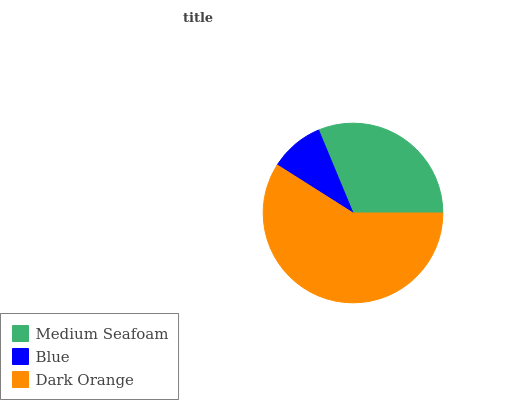Is Blue the minimum?
Answer yes or no. Yes. Is Dark Orange the maximum?
Answer yes or no. Yes. Is Dark Orange the minimum?
Answer yes or no. No. Is Blue the maximum?
Answer yes or no. No. Is Dark Orange greater than Blue?
Answer yes or no. Yes. Is Blue less than Dark Orange?
Answer yes or no. Yes. Is Blue greater than Dark Orange?
Answer yes or no. No. Is Dark Orange less than Blue?
Answer yes or no. No. Is Medium Seafoam the high median?
Answer yes or no. Yes. Is Medium Seafoam the low median?
Answer yes or no. Yes. Is Blue the high median?
Answer yes or no. No. Is Blue the low median?
Answer yes or no. No. 